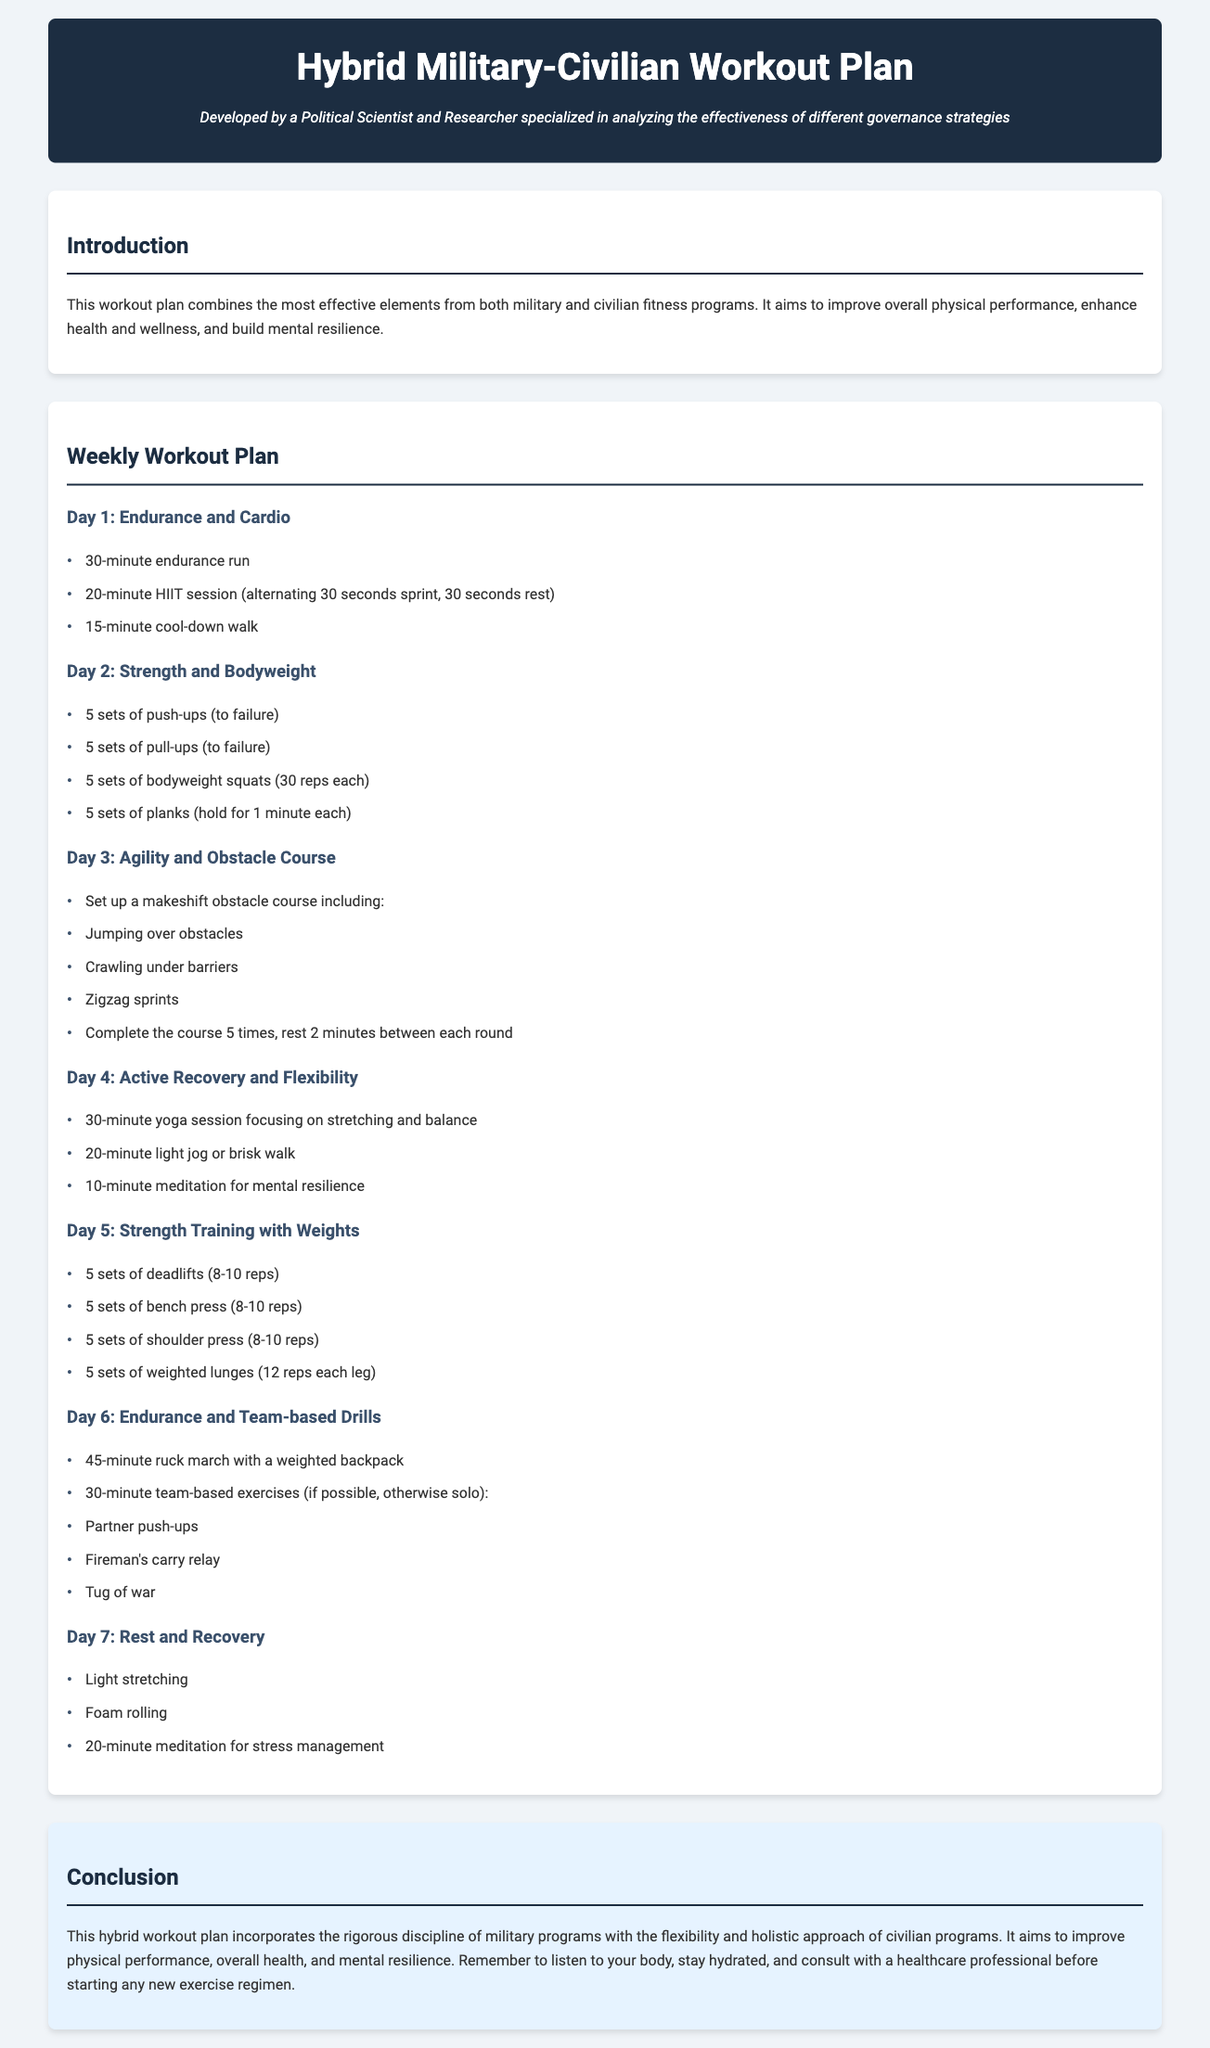What is the title of the document? The title of the document is provided in the header section of the HTML code.
Answer: Hybrid Military-Civilian Workout Plan Who developed the workout plan? The developer of the workout plan is noted in the subtitle of the header.
Answer: A Political Scientist and Researcher How many sets of push-ups are recommended? The workout plan specifies the number of sets for push-ups under Day 2.
Answer: 5 sets What is the total duration of the endurance run on Day 1? The duration of the endurance run is specifically mentioned in the Day 1 workout details.
Answer: 30-minute How many minutes is the yoga session on Day 4? The yoga session duration is clearly stated in the Day 4 workout section.
Answer: 30-minute What types of drills are included on Day 6? Day 6 specifies the type of exercises included during the team-based session.
Answer: Partner push-ups, Fireman's carry relay, Tug of war What is one activity suggested for Day 7's rest and recovery? The activities for Day 7 are detailed, focusing on recovery.
Answer: Light stretching What is the primary aim of the hybrid workout plan? The introduction of the document explains the primary aim of the workout plan.
Answer: Improve physical performance, overall health, and mental resilience 